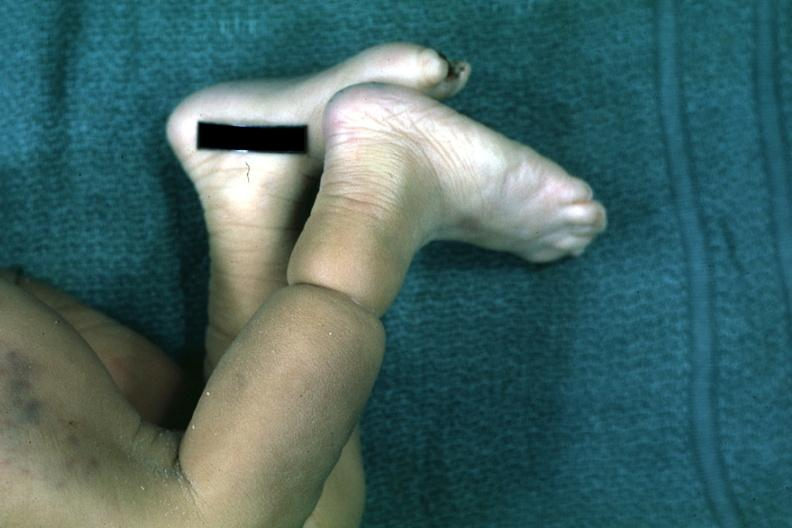what is present?
Answer the question using a single word or phrase. Foot 